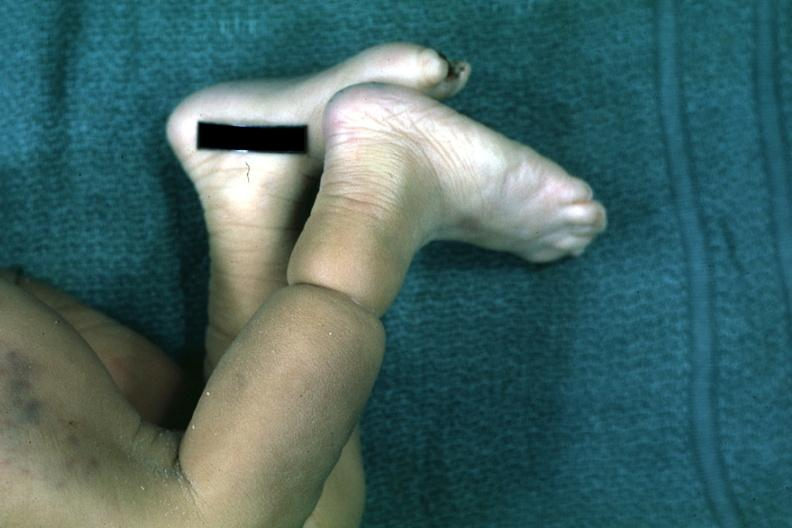what is present?
Answer the question using a single word or phrase. Foot 